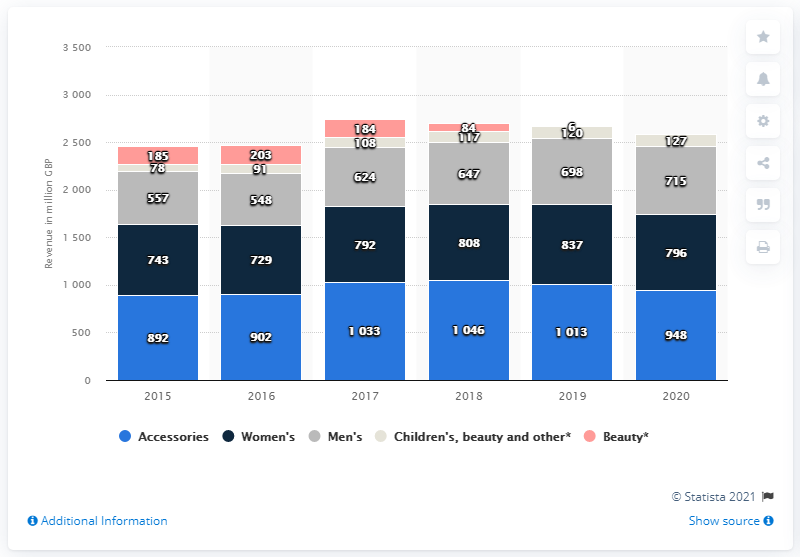Outline some significant characteristics in this image. Burberry's accessories channel generated a global revenue of 948 million in 2020. 